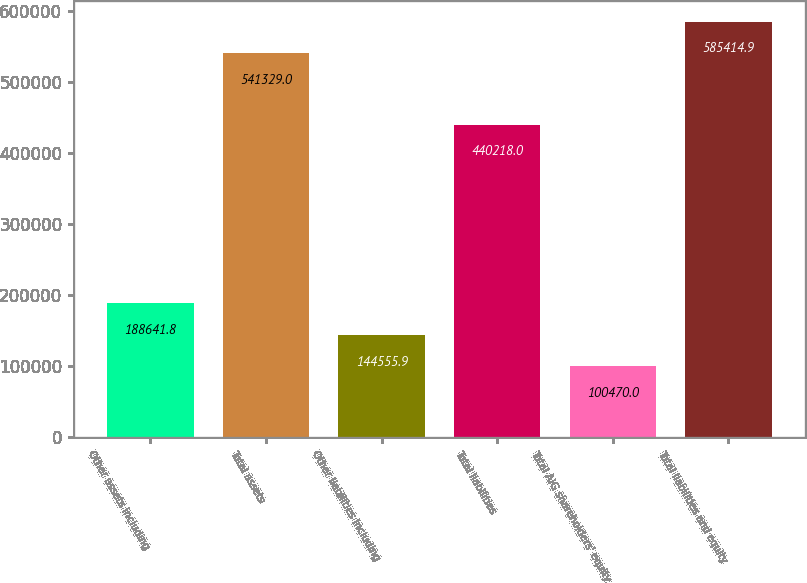Convert chart to OTSL. <chart><loc_0><loc_0><loc_500><loc_500><bar_chart><fcel>Other assets including<fcel>Total assets<fcel>Other liabilities including<fcel>Total liabilities<fcel>Total AIG shareholders' equity<fcel>Total liabilities and equity<nl><fcel>188642<fcel>541329<fcel>144556<fcel>440218<fcel>100470<fcel>585415<nl></chart> 